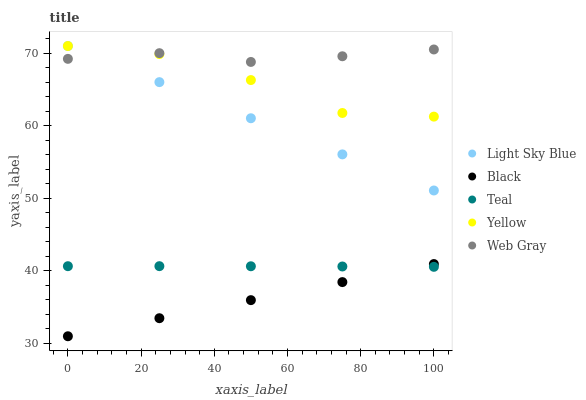Does Black have the minimum area under the curve?
Answer yes or no. Yes. Does Web Gray have the maximum area under the curve?
Answer yes or no. Yes. Does Light Sky Blue have the minimum area under the curve?
Answer yes or no. No. Does Light Sky Blue have the maximum area under the curve?
Answer yes or no. No. Is Light Sky Blue the smoothest?
Answer yes or no. Yes. Is Yellow the roughest?
Answer yes or no. Yes. Is Black the smoothest?
Answer yes or no. No. Is Black the roughest?
Answer yes or no. No. Does Black have the lowest value?
Answer yes or no. Yes. Does Light Sky Blue have the lowest value?
Answer yes or no. No. Does Yellow have the highest value?
Answer yes or no. Yes. Does Black have the highest value?
Answer yes or no. No. Is Black less than Web Gray?
Answer yes or no. Yes. Is Light Sky Blue greater than Black?
Answer yes or no. Yes. Does Black intersect Teal?
Answer yes or no. Yes. Is Black less than Teal?
Answer yes or no. No. Is Black greater than Teal?
Answer yes or no. No. Does Black intersect Web Gray?
Answer yes or no. No. 